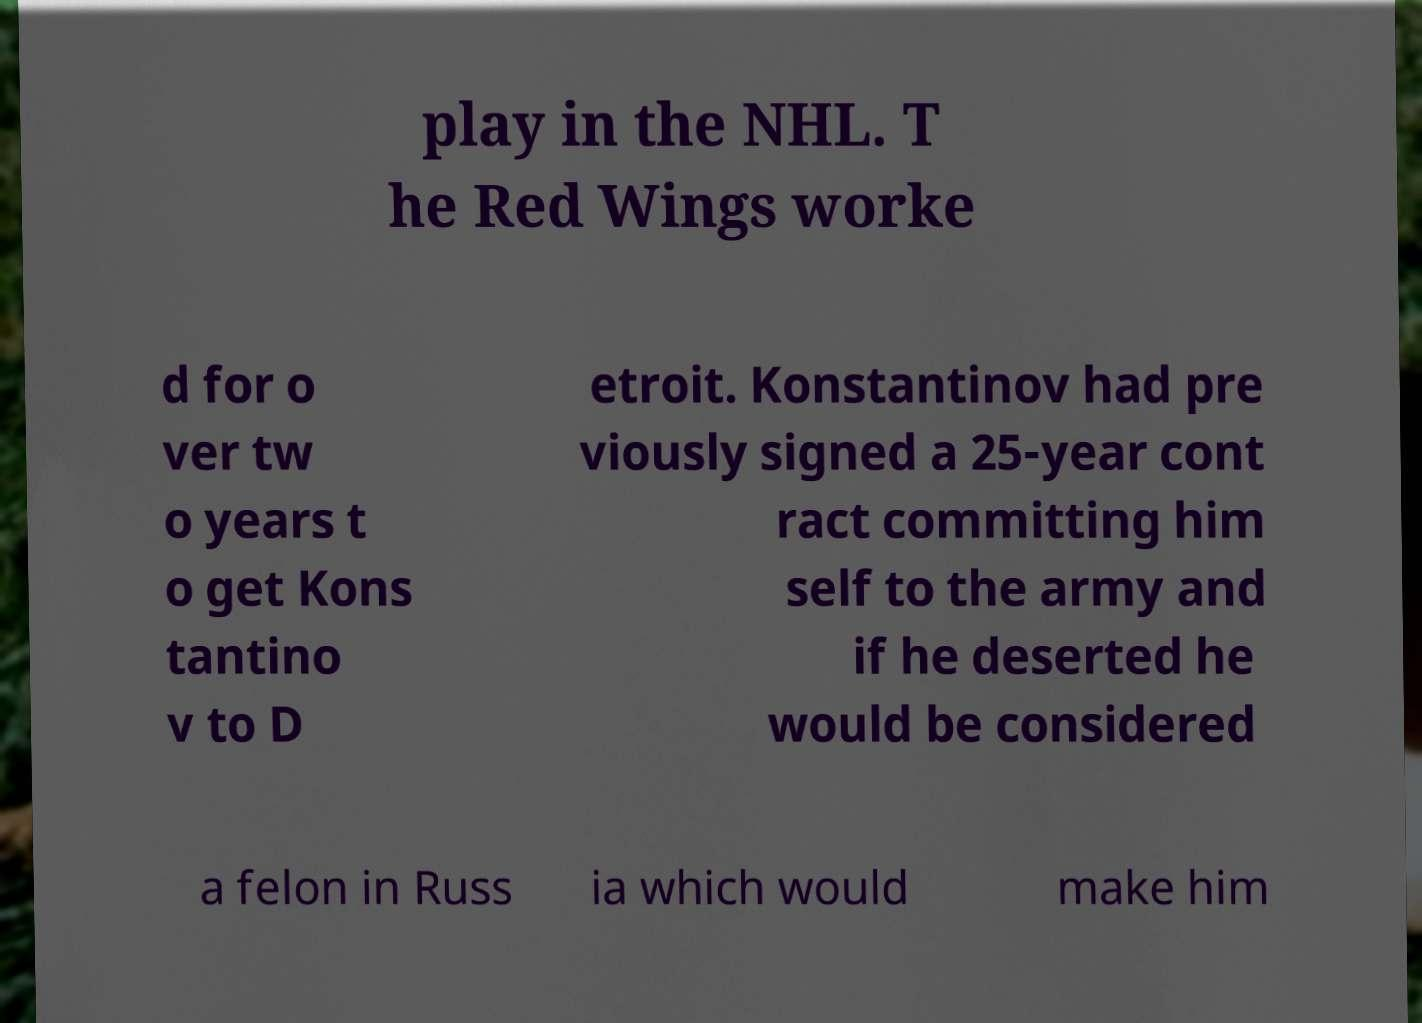What messages or text are displayed in this image? I need them in a readable, typed format. play in the NHL. T he Red Wings worke d for o ver tw o years t o get Kons tantino v to D etroit. Konstantinov had pre viously signed a 25-year cont ract committing him self to the army and if he deserted he would be considered a felon in Russ ia which would make him 